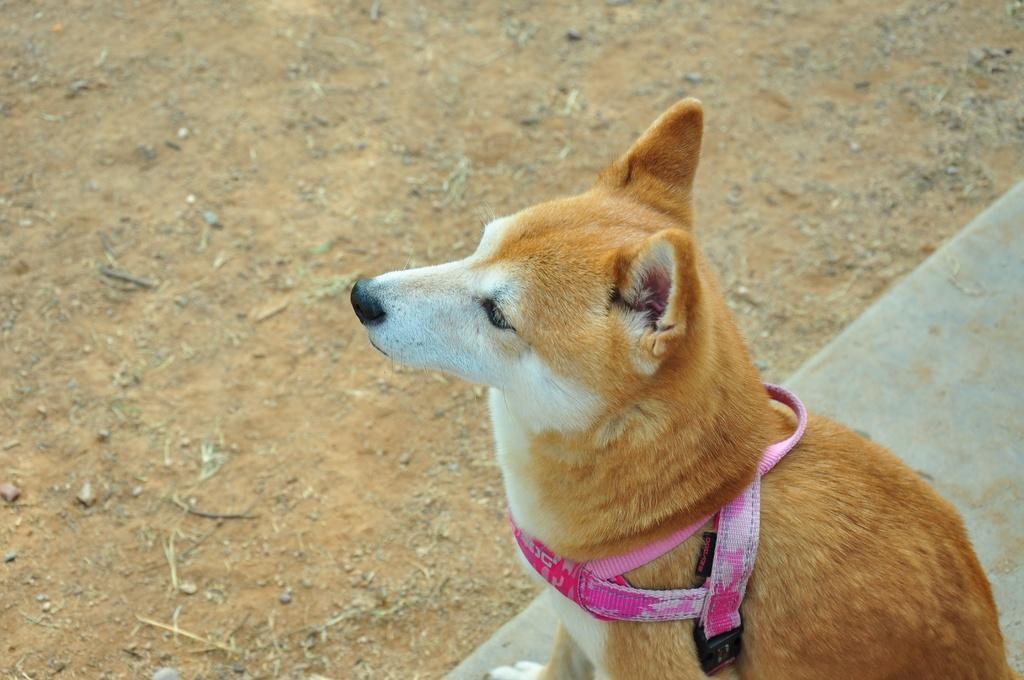In one or two sentences, can you explain what this image depicts? In this image, we can see a dog with belt on the surface. In the background, we can see the ground. 